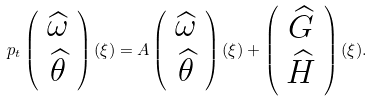<formula> <loc_0><loc_0><loc_500><loc_500>\ p _ { t } \left ( \begin{array} { c } \widehat { \omega } \\ \widehat { \theta } \\ \end{array} \right ) ( \xi ) = A \left ( \begin{array} { c } \widehat { \omega } \\ \widehat { \theta } \\ \end{array} \right ) ( \xi ) + \left ( \begin{array} { c } \widehat { G } \\ \widehat { H } \\ \end{array} \right ) ( \xi ) .</formula> 